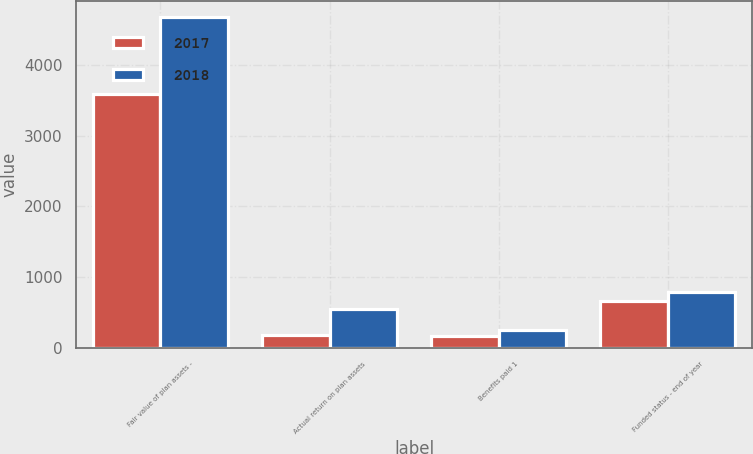Convert chart. <chart><loc_0><loc_0><loc_500><loc_500><stacked_bar_chart><ecel><fcel>Fair value of plan assets -<fcel>Actual return on plan assets<fcel>Benefits paid 1<fcel>Funded status - end of year<nl><fcel>2017<fcel>3592<fcel>172<fcel>161<fcel>656<nl><fcel>2018<fcel>4678<fcel>549<fcel>248<fcel>784<nl></chart> 